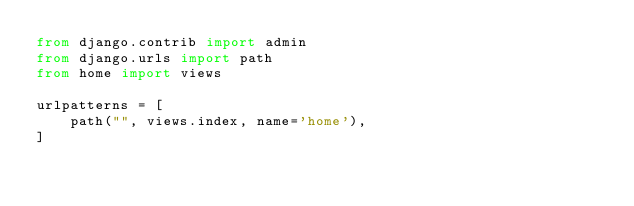<code> <loc_0><loc_0><loc_500><loc_500><_Python_>from django.contrib import admin
from django.urls import path
from home import views

urlpatterns = [
    path("", views.index, name='home'),
]
</code> 